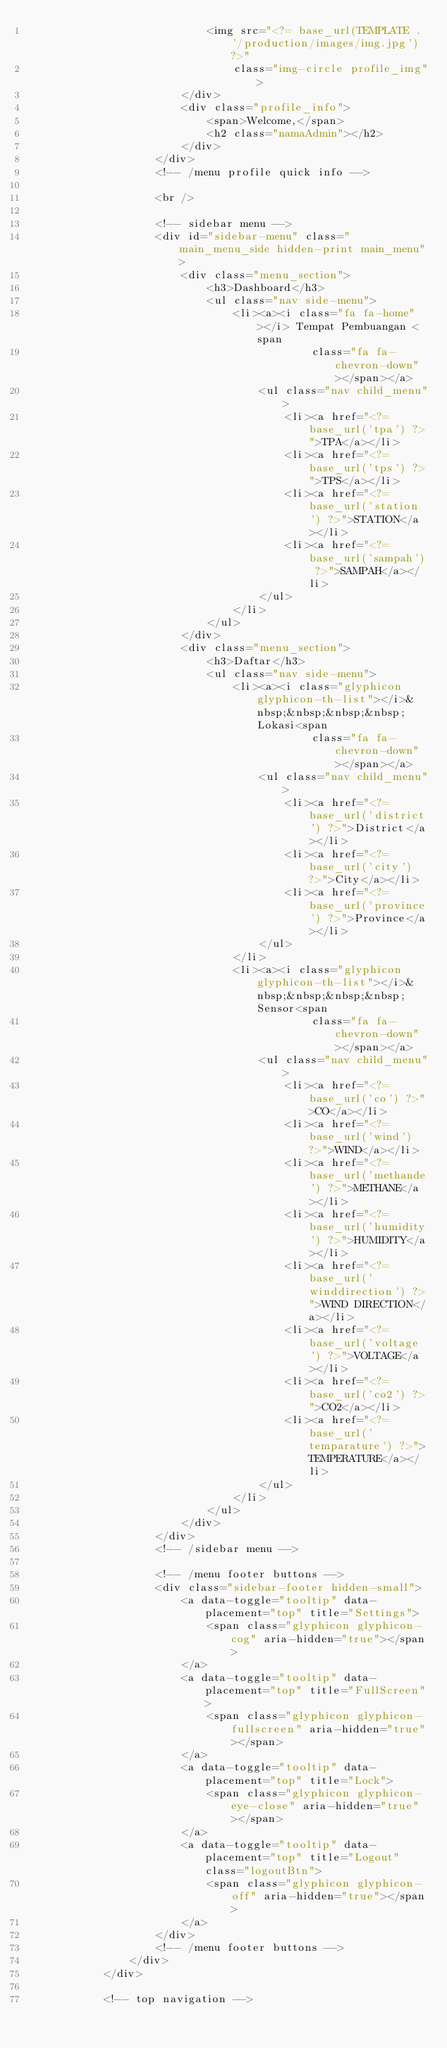<code> <loc_0><loc_0><loc_500><loc_500><_PHP_>                            <img src="<?= base_url(TEMPLATE . '/production/images/img.jpg') ?>"
                                class="img-circle profile_img">
                        </div>
                        <div class="profile_info">
                            <span>Welcome,</span>
                            <h2 class="namaAdmin"></h2>
                        </div>
                    </div>
                    <!-- /menu profile quick info -->

                    <br />

                    <!-- sidebar menu -->
                    <div id="sidebar-menu" class="main_menu_side hidden-print main_menu">
                        <div class="menu_section">
                            <h3>Dashboard</h3>
                            <ul class="nav side-menu">
                                <li><a><i class="fa fa-home"></i> Tempat Pembuangan <span
                                            class="fa fa-chevron-down"></span></a>
                                    <ul class="nav child_menu">
                                        <li><a href="<?= base_url('tpa') ?>">TPA</a></li>
                                        <li><a href="<?= base_url('tps') ?>">TPS</a></li>
                                        <li><a href="<?= base_url('station') ?>">STATION</a></li>
                                        <li><a href="<?= base_url('sampah') ?>">SAMPAH</a></li>
                                    </ul>
                                </li>
                            </ul>
                        </div>
                        <div class="menu_section">
                            <h3>Daftar</h3>
                            <ul class="nav side-menu">
                                <li><a><i class="glyphicon glyphicon-th-list"></i>&nbsp;&nbsp;&nbsp;&nbsp;Lokasi<span
                                            class="fa fa-chevron-down"></span></a>
                                    <ul class="nav child_menu">
                                        <li><a href="<?= base_url('district') ?>">District</a></li>
                                        <li><a href="<?= base_url('city') ?>">City</a></li>
                                        <li><a href="<?= base_url('province') ?>">Province</a></li>
                                    </ul>
                                </li>
                                <li><a><i class="glyphicon glyphicon-th-list"></i>&nbsp;&nbsp;&nbsp;&nbsp;Sensor<span
                                            class="fa fa-chevron-down"></span></a>
                                    <ul class="nav child_menu">
                                        <li><a href="<?= base_url('co') ?>">CO</a></li>
                                        <li><a href="<?= base_url('wind') ?>">WIND</a></li>
                                        <li><a href="<?= base_url('methande') ?>">METHANE</a></li>
                                        <li><a href="<?= base_url('humidity') ?>">HUMIDITY</a></li>
                                        <li><a href="<?= base_url('winddirection') ?>">WIND DIRECTION</a></li>
                                        <li><a href="<?= base_url('voltage') ?>">VOLTAGE</a></li>
                                        <li><a href="<?= base_url('co2') ?>">CO2</a></li>
                                        <li><a href="<?= base_url('temparature') ?>">TEMPERATURE</a></li>
                                    </ul>
                                </li>
                            </ul>
                        </div>
                    </div>
                    <!-- /sidebar menu -->

                    <!-- /menu footer buttons -->
                    <div class="sidebar-footer hidden-small">
                        <a data-toggle="tooltip" data-placement="top" title="Settings">
                            <span class="glyphicon glyphicon-cog" aria-hidden="true"></span>
                        </a>
                        <a data-toggle="tooltip" data-placement="top" title="FullScreen">
                            <span class="glyphicon glyphicon-fullscreen" aria-hidden="true"></span>
                        </a>
                        <a data-toggle="tooltip" data-placement="top" title="Lock">
                            <span class="glyphicon glyphicon-eye-close" aria-hidden="true"></span>
                        </a>
                        <a data-toggle="tooltip" data-placement="top" title="Logout" class="logoutBtn">
                            <span class="glyphicon glyphicon-off" aria-hidden="true"></span>
                        </a>
                    </div>
                    <!-- /menu footer buttons -->
                </div>
            </div>

            <!-- top navigation --></code> 